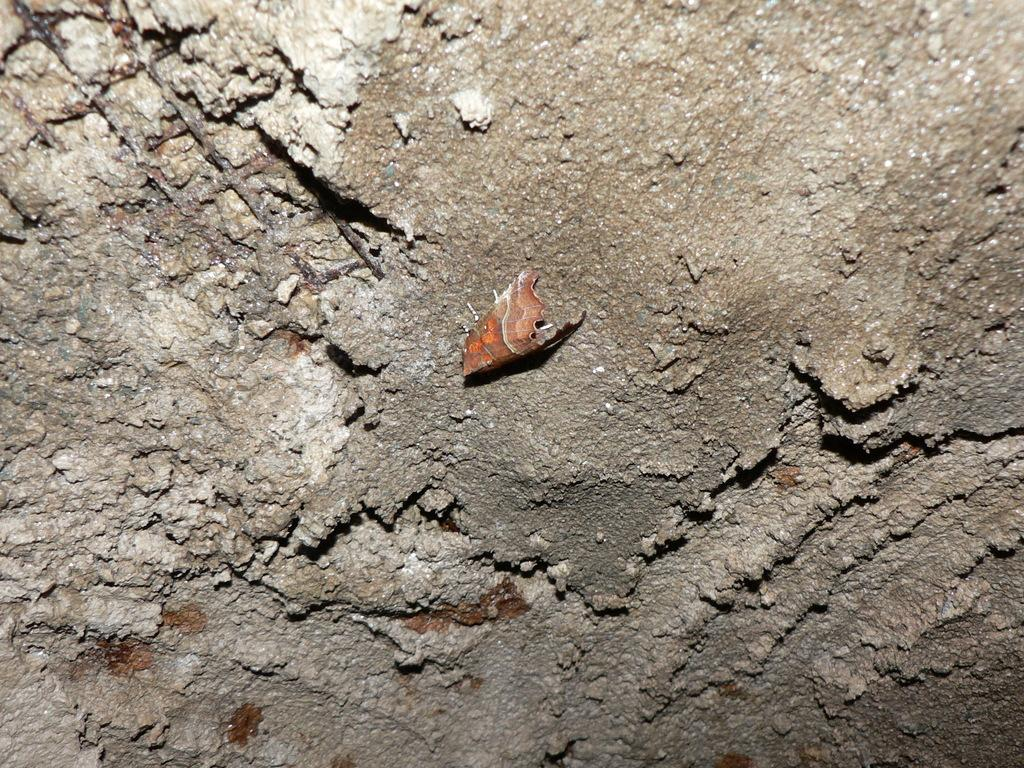What is the main substance in the image? There is a concrete mixture in the image. What other materials can be seen in the image? There are iron rods in the image. Are there any living organisms present in the image? Yes, there is a fly on the concrete mixture in the image. How does the concrete mixture start to whistle in the image? The concrete mixture does not whistle in the image; it is an inanimate substance. 